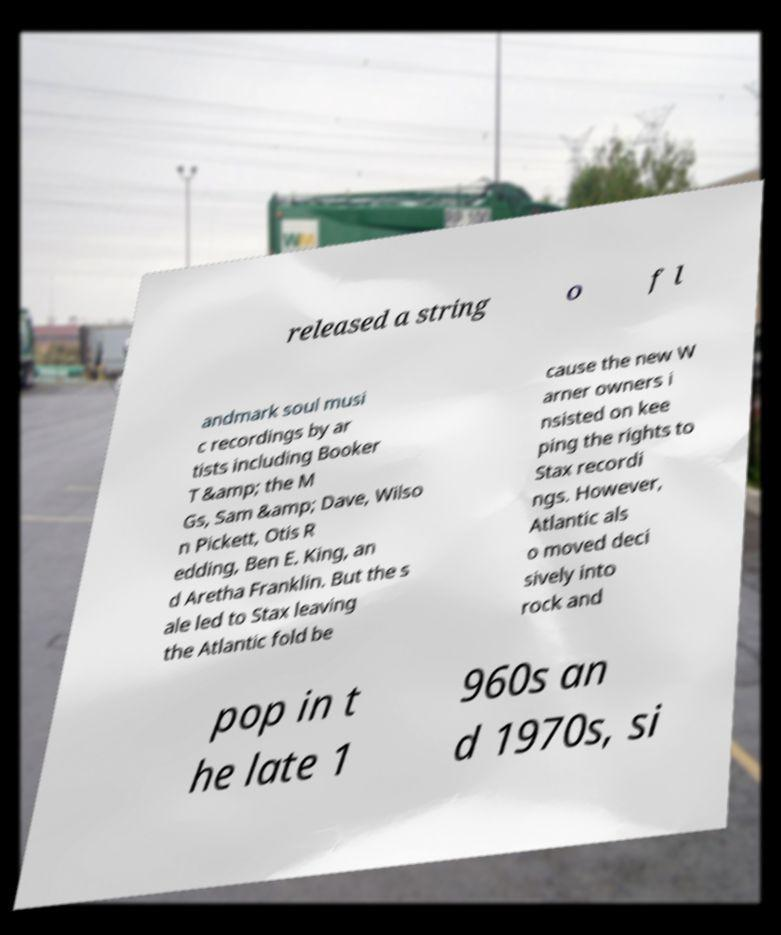Can you read and provide the text displayed in the image?This photo seems to have some interesting text. Can you extract and type it out for me? released a string o f l andmark soul musi c recordings by ar tists including Booker T &amp; the M Gs, Sam &amp; Dave, Wilso n Pickett, Otis R edding, Ben E. King, an d Aretha Franklin. But the s ale led to Stax leaving the Atlantic fold be cause the new W arner owners i nsisted on kee ping the rights to Stax recordi ngs. However, Atlantic als o moved deci sively into rock and pop in t he late 1 960s an d 1970s, si 